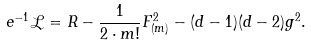<formula> <loc_0><loc_0><loc_500><loc_500>e ^ { - 1 } \mathcal { L } = R - { \frac { 1 } { 2 \cdot m ! } } F _ { ( m ) } ^ { 2 } - ( d - 1 ) ( d - 2 ) g ^ { 2 } .</formula> 